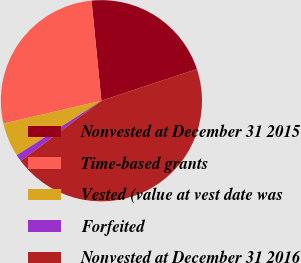Convert chart. <chart><loc_0><loc_0><loc_500><loc_500><pie_chart><fcel>Nonvested at December 31 2015<fcel>Time-based grants<fcel>Vested (value at vest date was<fcel>Forfeited<fcel>Nonvested at December 31 2016<nl><fcel>21.47%<fcel>27.08%<fcel>5.47%<fcel>1.09%<fcel>44.9%<nl></chart> 